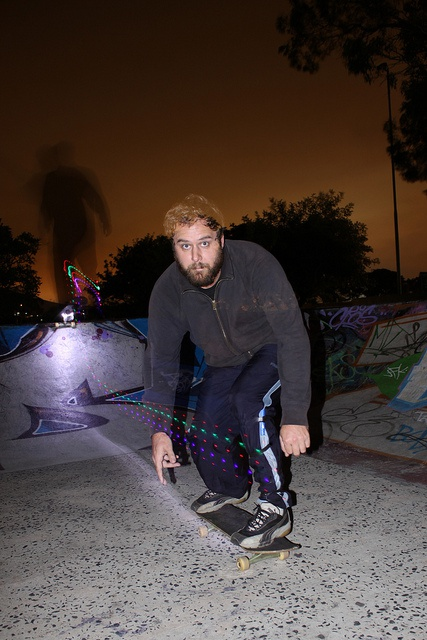Describe the objects in this image and their specific colors. I can see people in black, gray, and lightpink tones, people in black, maroon, and darkgreen tones, skateboard in black, darkgray, and gray tones, and skateboard in black, gray, darkgray, and lightgray tones in this image. 